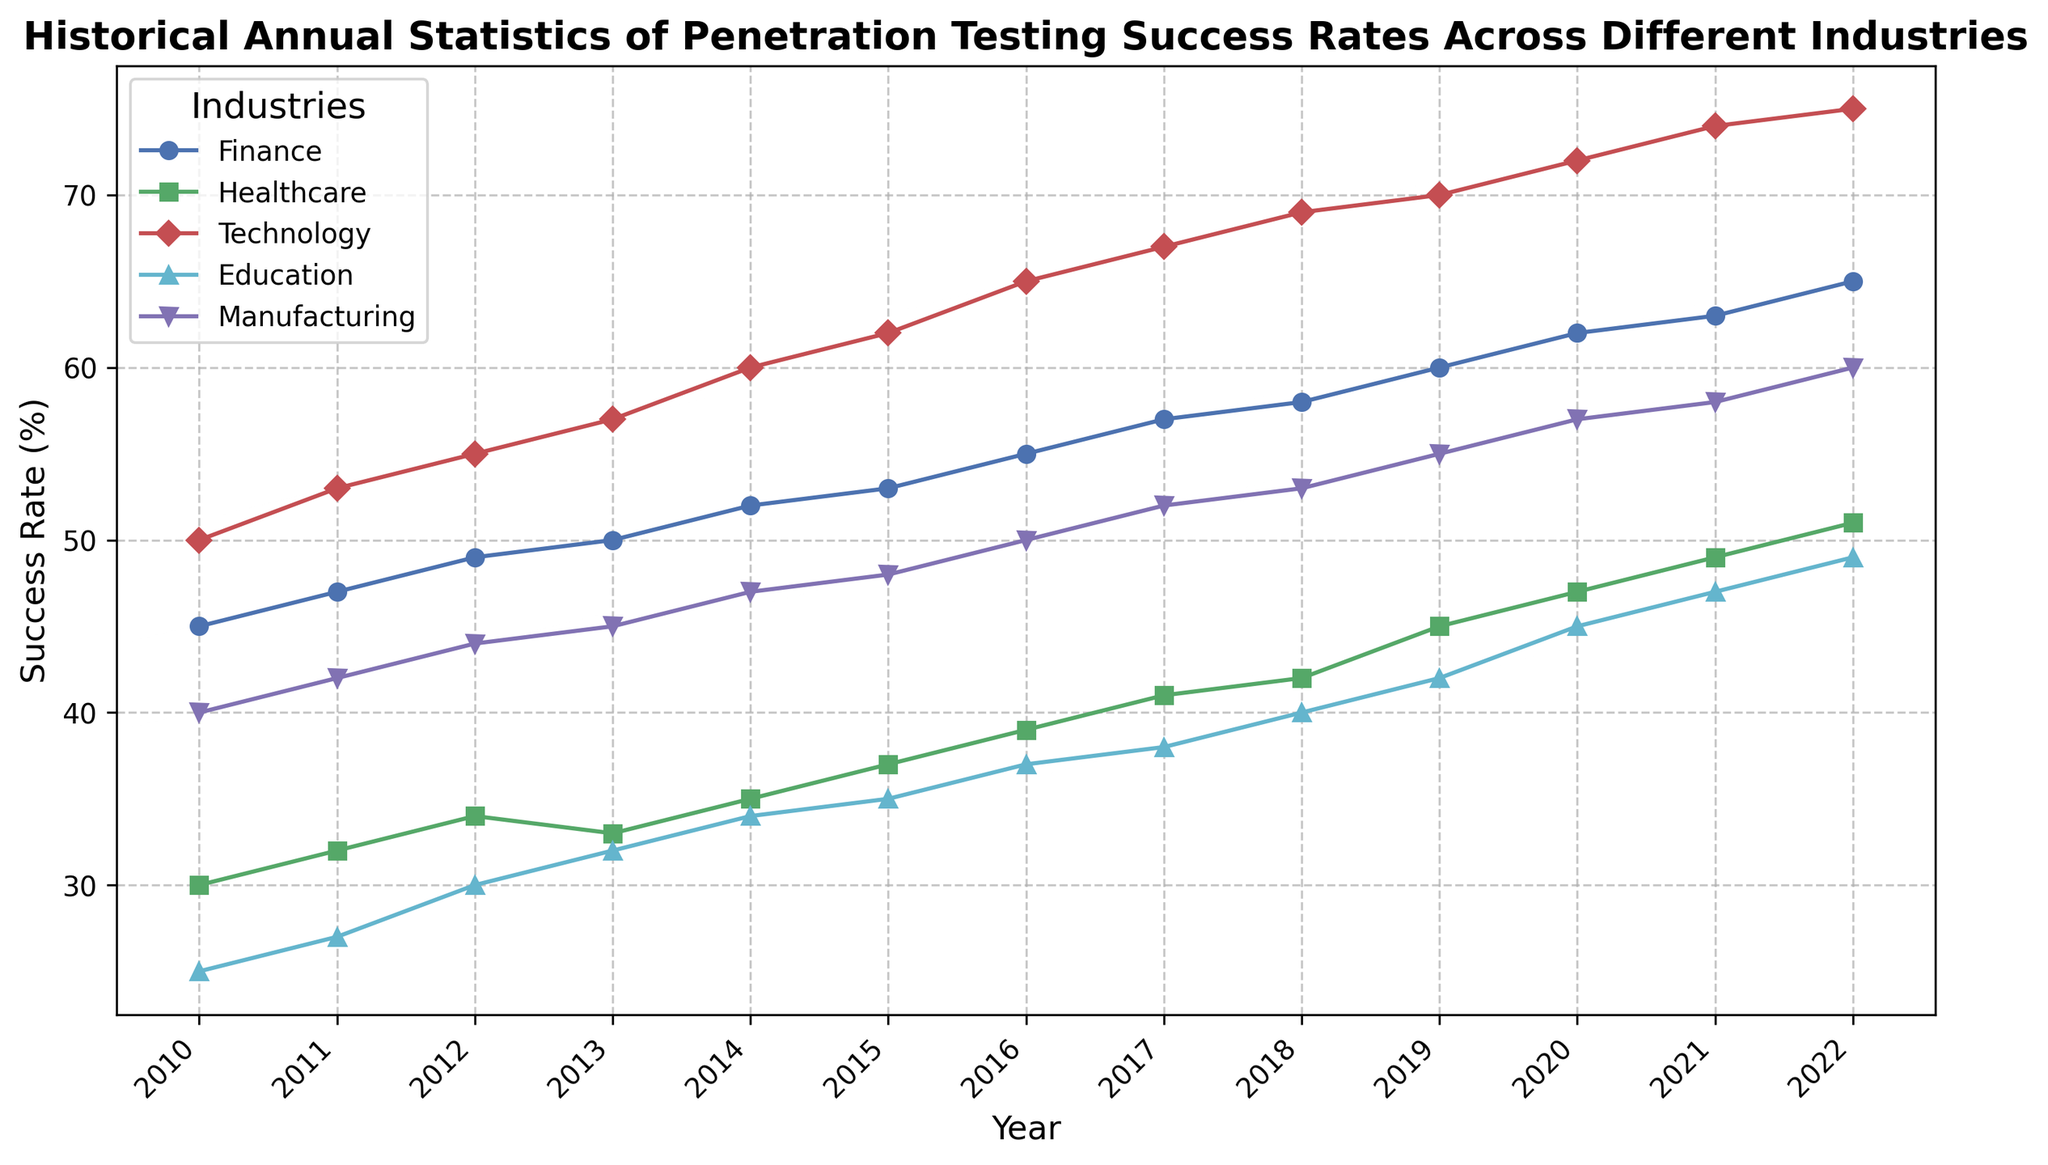What was the penetration testing success rate for the finance industry in 2013? Look for the data point for the finance industry in the year 2013. The value indicated is 50%.
Answer: 50% Which industry had the highest success rate in 2015? Compare the success rates of all industries for the year 2015. The technology industry has the highest rate at 62%.
Answer: Technology What is the difference in success rates between the technology and healthcare industries in 2021? For 2021, subtract the healthcare industry's success rate (49%) from the technology industry's success rate (74%). The difference is 25 percentage points.
Answer: 25% Between 2010 and 2022, which industry's success rate increased the most? Calculate the increase for each industry from 2010 to 2022 by subtracting the 2010 value from the 2022 value. The technology industry's success rate increased the most, from 50% to 75%, which is a 25 percentage point increase.
Answer: Technology What is the average success rate of the manufacturing industry from 2010 to 2022? Add the success rates of the manufacturing industry for each year from 2010 to 2022: `(40 + 42 + 44 + 45 + 47 + 48 + 50 + 52 + 53 + 55 + 57 + 58 + 60)`. The sum is 651. Divide this by the number of years (13) to get the average: `651 / 13 ≈ 50.08%`.
Answer: 50.08% In which year did the healthcare industry equal or surpass a success rate of 50%? Look at the data points for the healthcare industry and find the first year where the value is 50% or more. The year is 2022 with a success rate of 51%.
Answer: 2022 How many industries had a success rate greater than 60% in 2020? For the year 2020, count the number of industries with success rates above 60%. Both the technology (72%) and finance (62%) industries meet this criterion.
Answer: 2 Between which two consecutive years did the finance industry see the largest increase in success rate? Calculate the year-over-year differences for the finance industry success rates and identify the largest increase: 2018 to 2019 saw the largest increase from 58% to 60%, which is a 2 percentage point increase.
Answer: 2018-2019 What color represents the education industry's trend line in the chart? The plot described education industry's trend with the color cyan (`'c'`).
Answer: Cyan 